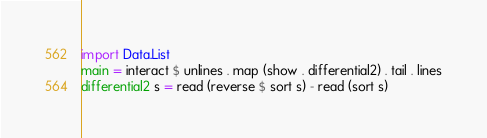Convert code to text. <code><loc_0><loc_0><loc_500><loc_500><_Haskell_>import Data.List
main = interact $ unlines . map (show . differential2) . tail . lines
differential2 s = read (reverse $ sort s) - read (sort s)</code> 